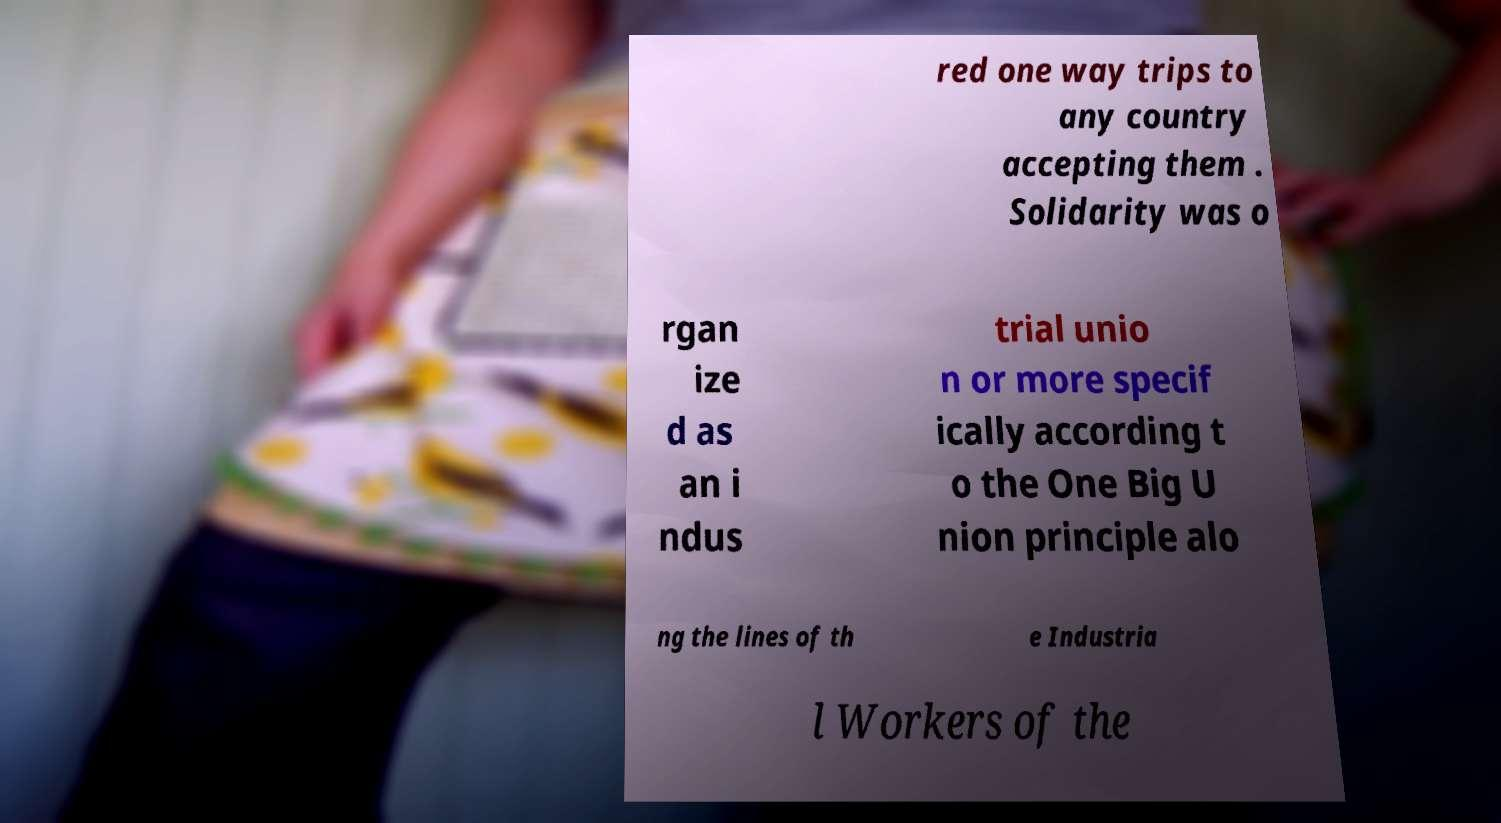Please read and relay the text visible in this image. What does it say? red one way trips to any country accepting them . Solidarity was o rgan ize d as an i ndus trial unio n or more specif ically according t o the One Big U nion principle alo ng the lines of th e Industria l Workers of the 